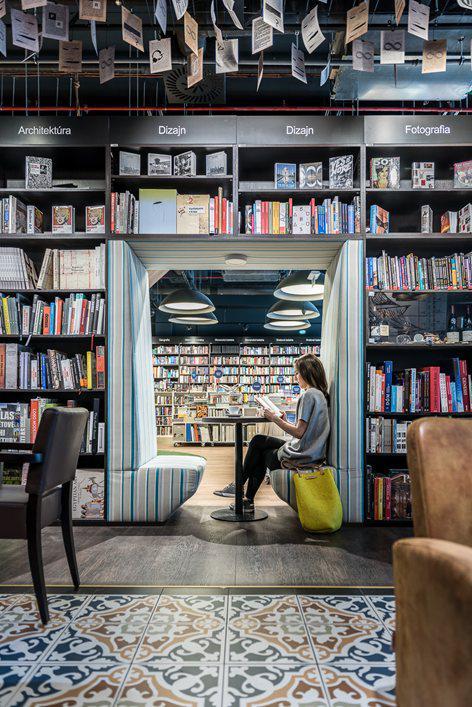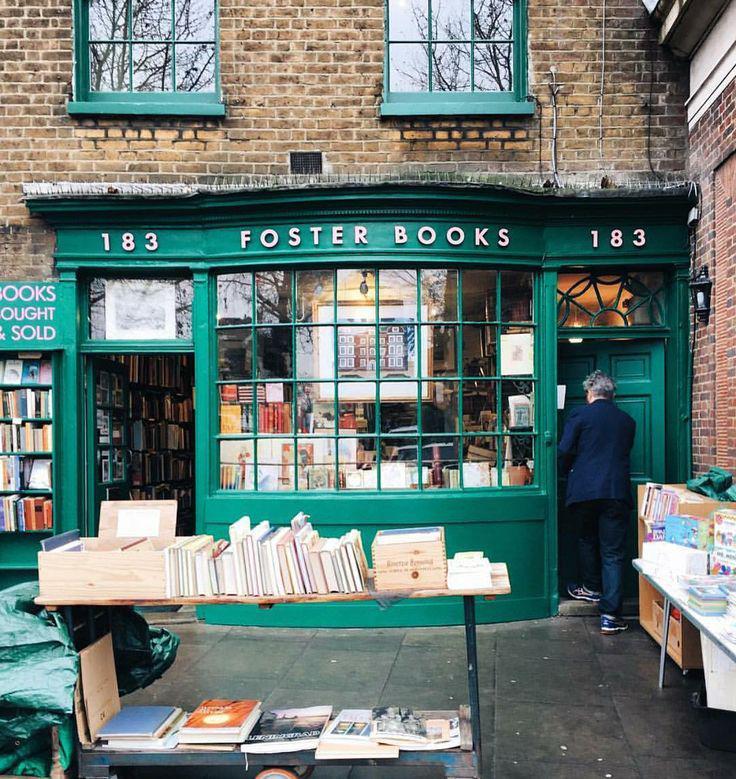The first image is the image on the left, the second image is the image on the right. Analyze the images presented: Is the assertion "In one image, at least one person is inside a book store that has books shelved to the ceiling." valid? Answer yes or no. Yes. The first image is the image on the left, the second image is the image on the right. Assess this claim about the two images: "Both images include book shop exteriors.". Correct or not? Answer yes or no. No. 